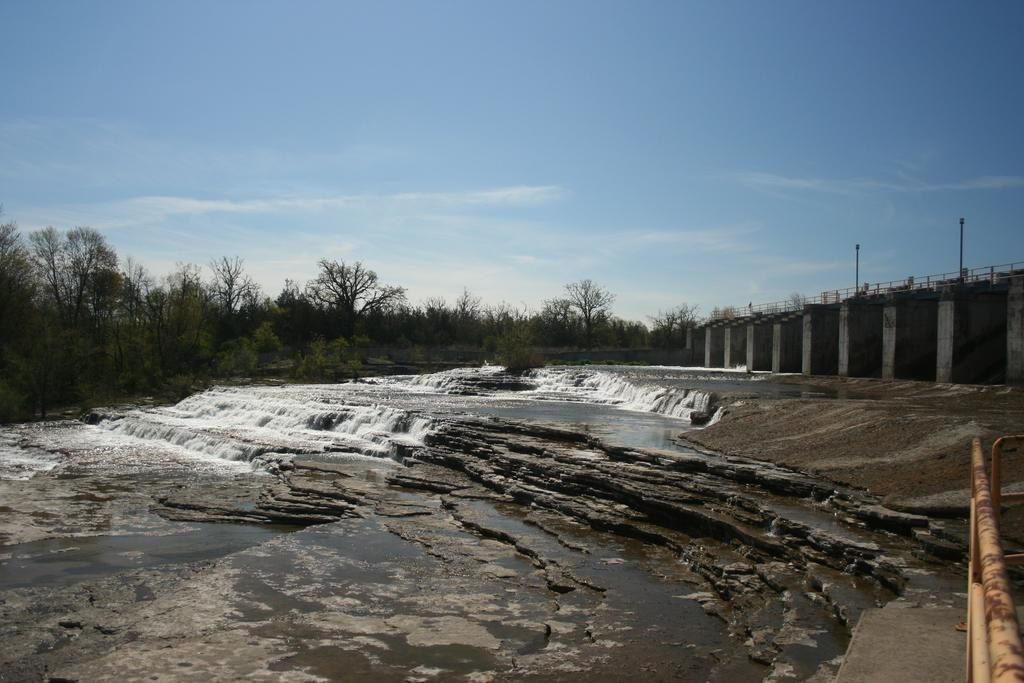What is happening in the center of the image? There is water flowing on stones in the center of the image. What can be seen in the background of the image? There are trees in the background of the image. What is located on the right side of the image? There is fencing on the right side of the image. Can you describe the rod in the image? Yes, there is a rod present in the image. How many doctors are visible in the image? There are no doctors present in the image. What type of tree is growing on the spot in the image? There is no tree growing on a spot in the image; the trees are in the background. 